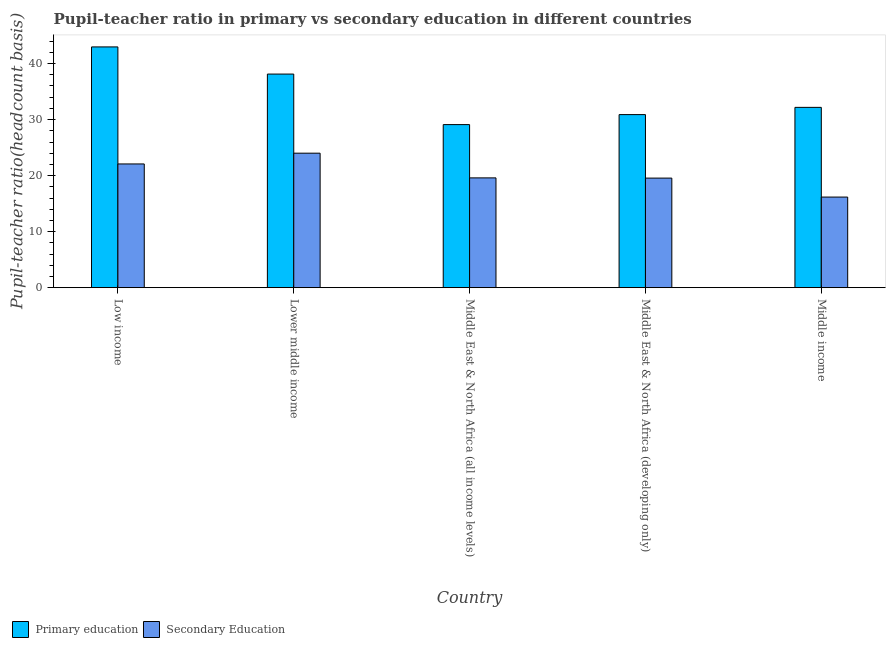How many different coloured bars are there?
Give a very brief answer. 2. Are the number of bars per tick equal to the number of legend labels?
Provide a short and direct response. Yes. Are the number of bars on each tick of the X-axis equal?
Offer a terse response. Yes. How many bars are there on the 4th tick from the right?
Provide a short and direct response. 2. What is the pupil teacher ratio on secondary education in Middle income?
Give a very brief answer. 16.17. Across all countries, what is the maximum pupil-teacher ratio in primary education?
Make the answer very short. 42.97. Across all countries, what is the minimum pupil teacher ratio on secondary education?
Make the answer very short. 16.17. In which country was the pupil-teacher ratio in primary education maximum?
Your response must be concise. Low income. In which country was the pupil-teacher ratio in primary education minimum?
Your answer should be very brief. Middle East & North Africa (all income levels). What is the total pupil-teacher ratio in primary education in the graph?
Provide a succinct answer. 173.28. What is the difference between the pupil-teacher ratio in primary education in Lower middle income and that in Middle income?
Ensure brevity in your answer.  5.94. What is the difference between the pupil-teacher ratio in primary education in Middle East & North Africa (developing only) and the pupil teacher ratio on secondary education in Middle East & North Africa (all income levels)?
Your answer should be compact. 11.3. What is the average pupil teacher ratio on secondary education per country?
Keep it short and to the point. 20.28. What is the difference between the pupil teacher ratio on secondary education and pupil-teacher ratio in primary education in Middle East & North Africa (developing only)?
Ensure brevity in your answer.  -11.33. What is the ratio of the pupil-teacher ratio in primary education in Lower middle income to that in Middle East & North Africa (developing only)?
Provide a succinct answer. 1.23. Is the pupil teacher ratio on secondary education in Middle East & North Africa (all income levels) less than that in Middle income?
Make the answer very short. No. What is the difference between the highest and the second highest pupil-teacher ratio in primary education?
Your answer should be very brief. 4.85. What is the difference between the highest and the lowest pupil teacher ratio on secondary education?
Make the answer very short. 7.84. In how many countries, is the pupil-teacher ratio in primary education greater than the average pupil-teacher ratio in primary education taken over all countries?
Ensure brevity in your answer.  2. What does the 1st bar from the left in Middle income represents?
Provide a succinct answer. Primary education. What does the 2nd bar from the right in Middle East & North Africa (developing only) represents?
Your answer should be compact. Primary education. How many bars are there?
Give a very brief answer. 10. Are all the bars in the graph horizontal?
Provide a short and direct response. No. Does the graph contain any zero values?
Keep it short and to the point. No. What is the title of the graph?
Your response must be concise. Pupil-teacher ratio in primary vs secondary education in different countries. What is the label or title of the Y-axis?
Offer a terse response. Pupil-teacher ratio(headcount basis). What is the Pupil-teacher ratio(headcount basis) of Primary education in Low income?
Offer a terse response. 42.97. What is the Pupil-teacher ratio(headcount basis) in Secondary Education in Low income?
Provide a short and direct response. 22.08. What is the Pupil-teacher ratio(headcount basis) in Primary education in Lower middle income?
Make the answer very short. 38.13. What is the Pupil-teacher ratio(headcount basis) of Secondary Education in Lower middle income?
Your response must be concise. 24.01. What is the Pupil-teacher ratio(headcount basis) in Primary education in Middle East & North Africa (all income levels)?
Ensure brevity in your answer.  29.11. What is the Pupil-teacher ratio(headcount basis) in Secondary Education in Middle East & North Africa (all income levels)?
Provide a succinct answer. 19.59. What is the Pupil-teacher ratio(headcount basis) in Primary education in Middle East & North Africa (developing only)?
Provide a short and direct response. 30.89. What is the Pupil-teacher ratio(headcount basis) in Secondary Education in Middle East & North Africa (developing only)?
Offer a very short reply. 19.56. What is the Pupil-teacher ratio(headcount basis) of Primary education in Middle income?
Make the answer very short. 32.18. What is the Pupil-teacher ratio(headcount basis) in Secondary Education in Middle income?
Ensure brevity in your answer.  16.17. Across all countries, what is the maximum Pupil-teacher ratio(headcount basis) of Primary education?
Ensure brevity in your answer.  42.97. Across all countries, what is the maximum Pupil-teacher ratio(headcount basis) of Secondary Education?
Provide a short and direct response. 24.01. Across all countries, what is the minimum Pupil-teacher ratio(headcount basis) in Primary education?
Your answer should be very brief. 29.11. Across all countries, what is the minimum Pupil-teacher ratio(headcount basis) in Secondary Education?
Make the answer very short. 16.17. What is the total Pupil-teacher ratio(headcount basis) in Primary education in the graph?
Make the answer very short. 173.28. What is the total Pupil-teacher ratio(headcount basis) in Secondary Education in the graph?
Give a very brief answer. 101.41. What is the difference between the Pupil-teacher ratio(headcount basis) in Primary education in Low income and that in Lower middle income?
Give a very brief answer. 4.85. What is the difference between the Pupil-teacher ratio(headcount basis) in Secondary Education in Low income and that in Lower middle income?
Give a very brief answer. -1.92. What is the difference between the Pupil-teacher ratio(headcount basis) of Primary education in Low income and that in Middle East & North Africa (all income levels)?
Give a very brief answer. 13.87. What is the difference between the Pupil-teacher ratio(headcount basis) of Secondary Education in Low income and that in Middle East & North Africa (all income levels)?
Your answer should be compact. 2.49. What is the difference between the Pupil-teacher ratio(headcount basis) of Primary education in Low income and that in Middle East & North Africa (developing only)?
Offer a terse response. 12.08. What is the difference between the Pupil-teacher ratio(headcount basis) of Secondary Education in Low income and that in Middle East & North Africa (developing only)?
Give a very brief answer. 2.52. What is the difference between the Pupil-teacher ratio(headcount basis) in Primary education in Low income and that in Middle income?
Make the answer very short. 10.79. What is the difference between the Pupil-teacher ratio(headcount basis) in Secondary Education in Low income and that in Middle income?
Offer a very short reply. 5.91. What is the difference between the Pupil-teacher ratio(headcount basis) of Primary education in Lower middle income and that in Middle East & North Africa (all income levels)?
Keep it short and to the point. 9.02. What is the difference between the Pupil-teacher ratio(headcount basis) of Secondary Education in Lower middle income and that in Middle East & North Africa (all income levels)?
Your response must be concise. 4.41. What is the difference between the Pupil-teacher ratio(headcount basis) of Primary education in Lower middle income and that in Middle East & North Africa (developing only)?
Keep it short and to the point. 7.23. What is the difference between the Pupil-teacher ratio(headcount basis) of Secondary Education in Lower middle income and that in Middle East & North Africa (developing only)?
Ensure brevity in your answer.  4.45. What is the difference between the Pupil-teacher ratio(headcount basis) in Primary education in Lower middle income and that in Middle income?
Ensure brevity in your answer.  5.94. What is the difference between the Pupil-teacher ratio(headcount basis) of Secondary Education in Lower middle income and that in Middle income?
Make the answer very short. 7.83. What is the difference between the Pupil-teacher ratio(headcount basis) in Primary education in Middle East & North Africa (all income levels) and that in Middle East & North Africa (developing only)?
Your answer should be very brief. -1.78. What is the difference between the Pupil-teacher ratio(headcount basis) in Secondary Education in Middle East & North Africa (all income levels) and that in Middle East & North Africa (developing only)?
Your answer should be very brief. 0.04. What is the difference between the Pupil-teacher ratio(headcount basis) in Primary education in Middle East & North Africa (all income levels) and that in Middle income?
Your answer should be compact. -3.08. What is the difference between the Pupil-teacher ratio(headcount basis) of Secondary Education in Middle East & North Africa (all income levels) and that in Middle income?
Provide a succinct answer. 3.42. What is the difference between the Pupil-teacher ratio(headcount basis) of Primary education in Middle East & North Africa (developing only) and that in Middle income?
Give a very brief answer. -1.29. What is the difference between the Pupil-teacher ratio(headcount basis) of Secondary Education in Middle East & North Africa (developing only) and that in Middle income?
Make the answer very short. 3.39. What is the difference between the Pupil-teacher ratio(headcount basis) in Primary education in Low income and the Pupil-teacher ratio(headcount basis) in Secondary Education in Lower middle income?
Your response must be concise. 18.97. What is the difference between the Pupil-teacher ratio(headcount basis) of Primary education in Low income and the Pupil-teacher ratio(headcount basis) of Secondary Education in Middle East & North Africa (all income levels)?
Offer a very short reply. 23.38. What is the difference between the Pupil-teacher ratio(headcount basis) in Primary education in Low income and the Pupil-teacher ratio(headcount basis) in Secondary Education in Middle East & North Africa (developing only)?
Give a very brief answer. 23.42. What is the difference between the Pupil-teacher ratio(headcount basis) of Primary education in Low income and the Pupil-teacher ratio(headcount basis) of Secondary Education in Middle income?
Provide a succinct answer. 26.8. What is the difference between the Pupil-teacher ratio(headcount basis) in Primary education in Lower middle income and the Pupil-teacher ratio(headcount basis) in Secondary Education in Middle East & North Africa (all income levels)?
Ensure brevity in your answer.  18.53. What is the difference between the Pupil-teacher ratio(headcount basis) in Primary education in Lower middle income and the Pupil-teacher ratio(headcount basis) in Secondary Education in Middle East & North Africa (developing only)?
Provide a short and direct response. 18.57. What is the difference between the Pupil-teacher ratio(headcount basis) in Primary education in Lower middle income and the Pupil-teacher ratio(headcount basis) in Secondary Education in Middle income?
Give a very brief answer. 21.95. What is the difference between the Pupil-teacher ratio(headcount basis) of Primary education in Middle East & North Africa (all income levels) and the Pupil-teacher ratio(headcount basis) of Secondary Education in Middle East & North Africa (developing only)?
Make the answer very short. 9.55. What is the difference between the Pupil-teacher ratio(headcount basis) in Primary education in Middle East & North Africa (all income levels) and the Pupil-teacher ratio(headcount basis) in Secondary Education in Middle income?
Make the answer very short. 12.94. What is the difference between the Pupil-teacher ratio(headcount basis) in Primary education in Middle East & North Africa (developing only) and the Pupil-teacher ratio(headcount basis) in Secondary Education in Middle income?
Keep it short and to the point. 14.72. What is the average Pupil-teacher ratio(headcount basis) of Primary education per country?
Provide a succinct answer. 34.66. What is the average Pupil-teacher ratio(headcount basis) in Secondary Education per country?
Make the answer very short. 20.28. What is the difference between the Pupil-teacher ratio(headcount basis) of Primary education and Pupil-teacher ratio(headcount basis) of Secondary Education in Low income?
Your response must be concise. 20.89. What is the difference between the Pupil-teacher ratio(headcount basis) in Primary education and Pupil-teacher ratio(headcount basis) in Secondary Education in Lower middle income?
Keep it short and to the point. 14.12. What is the difference between the Pupil-teacher ratio(headcount basis) of Primary education and Pupil-teacher ratio(headcount basis) of Secondary Education in Middle East & North Africa (all income levels)?
Your answer should be very brief. 9.51. What is the difference between the Pupil-teacher ratio(headcount basis) in Primary education and Pupil-teacher ratio(headcount basis) in Secondary Education in Middle East & North Africa (developing only)?
Keep it short and to the point. 11.33. What is the difference between the Pupil-teacher ratio(headcount basis) of Primary education and Pupil-teacher ratio(headcount basis) of Secondary Education in Middle income?
Make the answer very short. 16.01. What is the ratio of the Pupil-teacher ratio(headcount basis) of Primary education in Low income to that in Lower middle income?
Make the answer very short. 1.13. What is the ratio of the Pupil-teacher ratio(headcount basis) in Secondary Education in Low income to that in Lower middle income?
Provide a short and direct response. 0.92. What is the ratio of the Pupil-teacher ratio(headcount basis) in Primary education in Low income to that in Middle East & North Africa (all income levels)?
Ensure brevity in your answer.  1.48. What is the ratio of the Pupil-teacher ratio(headcount basis) in Secondary Education in Low income to that in Middle East & North Africa (all income levels)?
Your response must be concise. 1.13. What is the ratio of the Pupil-teacher ratio(headcount basis) of Primary education in Low income to that in Middle East & North Africa (developing only)?
Your answer should be very brief. 1.39. What is the ratio of the Pupil-teacher ratio(headcount basis) of Secondary Education in Low income to that in Middle East & North Africa (developing only)?
Make the answer very short. 1.13. What is the ratio of the Pupil-teacher ratio(headcount basis) of Primary education in Low income to that in Middle income?
Give a very brief answer. 1.34. What is the ratio of the Pupil-teacher ratio(headcount basis) of Secondary Education in Low income to that in Middle income?
Make the answer very short. 1.37. What is the ratio of the Pupil-teacher ratio(headcount basis) of Primary education in Lower middle income to that in Middle East & North Africa (all income levels)?
Keep it short and to the point. 1.31. What is the ratio of the Pupil-teacher ratio(headcount basis) in Secondary Education in Lower middle income to that in Middle East & North Africa (all income levels)?
Your response must be concise. 1.23. What is the ratio of the Pupil-teacher ratio(headcount basis) of Primary education in Lower middle income to that in Middle East & North Africa (developing only)?
Keep it short and to the point. 1.23. What is the ratio of the Pupil-teacher ratio(headcount basis) in Secondary Education in Lower middle income to that in Middle East & North Africa (developing only)?
Provide a succinct answer. 1.23. What is the ratio of the Pupil-teacher ratio(headcount basis) in Primary education in Lower middle income to that in Middle income?
Give a very brief answer. 1.18. What is the ratio of the Pupil-teacher ratio(headcount basis) in Secondary Education in Lower middle income to that in Middle income?
Offer a very short reply. 1.48. What is the ratio of the Pupil-teacher ratio(headcount basis) of Primary education in Middle East & North Africa (all income levels) to that in Middle East & North Africa (developing only)?
Your response must be concise. 0.94. What is the ratio of the Pupil-teacher ratio(headcount basis) in Secondary Education in Middle East & North Africa (all income levels) to that in Middle East & North Africa (developing only)?
Provide a succinct answer. 1. What is the ratio of the Pupil-teacher ratio(headcount basis) of Primary education in Middle East & North Africa (all income levels) to that in Middle income?
Your answer should be compact. 0.9. What is the ratio of the Pupil-teacher ratio(headcount basis) in Secondary Education in Middle East & North Africa (all income levels) to that in Middle income?
Provide a short and direct response. 1.21. What is the ratio of the Pupil-teacher ratio(headcount basis) in Primary education in Middle East & North Africa (developing only) to that in Middle income?
Offer a terse response. 0.96. What is the ratio of the Pupil-teacher ratio(headcount basis) of Secondary Education in Middle East & North Africa (developing only) to that in Middle income?
Offer a terse response. 1.21. What is the difference between the highest and the second highest Pupil-teacher ratio(headcount basis) of Primary education?
Give a very brief answer. 4.85. What is the difference between the highest and the second highest Pupil-teacher ratio(headcount basis) of Secondary Education?
Your answer should be compact. 1.92. What is the difference between the highest and the lowest Pupil-teacher ratio(headcount basis) of Primary education?
Your response must be concise. 13.87. What is the difference between the highest and the lowest Pupil-teacher ratio(headcount basis) of Secondary Education?
Your answer should be compact. 7.83. 